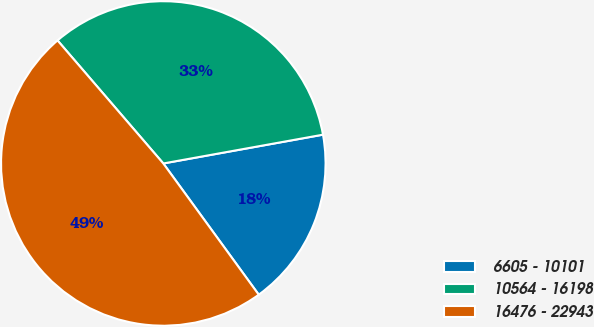Convert chart to OTSL. <chart><loc_0><loc_0><loc_500><loc_500><pie_chart><fcel>6605 - 10101<fcel>10564 - 16198<fcel>16476 - 22943<nl><fcel>17.83%<fcel>33.46%<fcel>48.7%<nl></chart> 